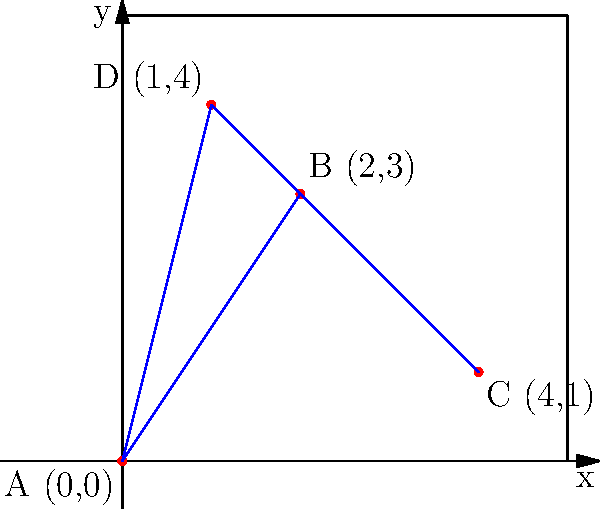Yo, fellow music lover! Check out this sick graph showing the sales of four popular Christmas albums. Each point represents an album's position based on its digital and physical sales. If we connect these points, we get a polygon. What's the area of this festive shape? Round your answer to the nearest whole number.

A (0,0): "All I Want for Christmas Is You" by Mariah Carey
B (2,3): "Christmas" by Michael Bublé
C (4,1): "A Charlie Brown Christmas" by Vince Guaraldi Trio
D (1,4): "Merry Christmas" by Bing Crosby Alright, let's break this down step by step:

1) We can calculate the area of this polygon using the Shoelace formula (also known as the surveyor's formula). The formula is:

   $$Area = \frac{1}{2}|x_1y_2 + x_2y_3 + x_3y_4 + x_4y_1 - y_1x_2 - y_2x_3 - y_3x_4 - y_4x_1|$$

2) Let's plug in our coordinates:
   A (0,0), B (2,3), C (4,1), D (1,4)

3) Now, let's calculate each term:
   
   $x_1y_2 = 0 * 3 = 0$
   $x_2y_3 = 2 * 1 = 2$
   $x_3y_4 = 4 * 4 = 16$
   $x_4y_1 = 1 * 0 = 0$
   $y_1x_2 = 0 * 2 = 0$
   $y_2x_3 = 3 * 4 = 12$
   $y_3x_4 = 1 * 1 = 1$
   $y_4x_1 = 4 * 0 = 0$

4) Let's sum it up:
   
   $$Area = \frac{1}{2}|(0 + 2 + 16 + 0) - (0 + 12 + 1 + 0)|$$
   
   $$= \frac{1}{2}|18 - 13|$$
   
   $$= \frac{1}{2} * 5 = 2.5$$

5) Rounding to the nearest whole number, we get 3.

So, the area of our Christmas album sales polygon is approximately 3 square units!
Answer: 3 square units 